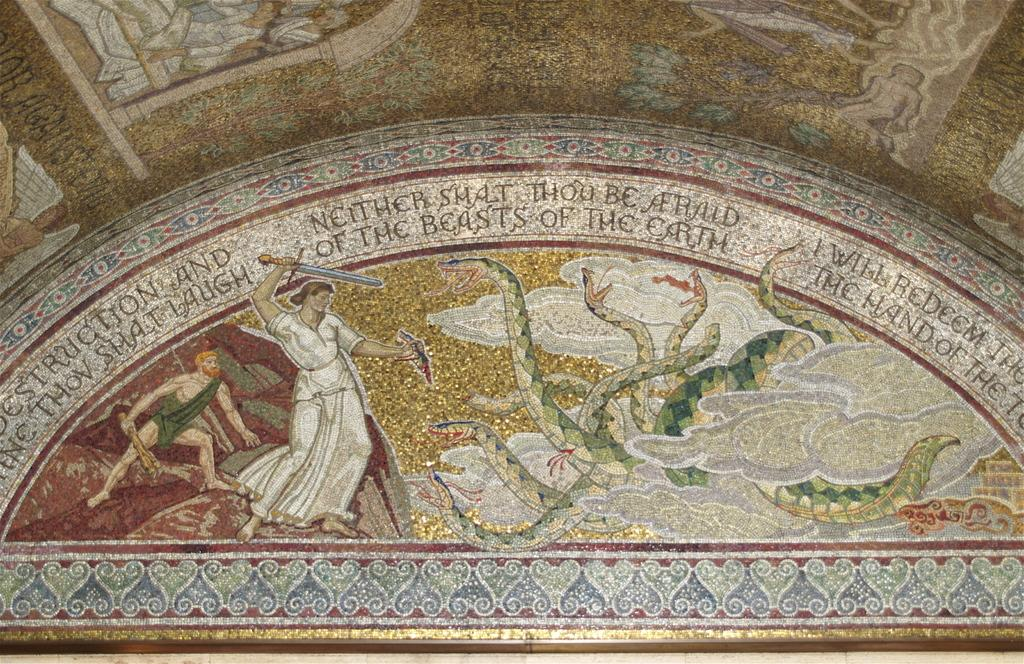What is depicted on the wall in the image? There is a wall painting in the image. What elements are included in the wall painting? The wall painting contains text and cartoon pictures. What type of science experiment is being conducted in the image? There is no science experiment present in the image; it features a wall painting with text and cartoon pictures. Can you tell me how many bridges are visible in the image? There are no bridges present in the image. 